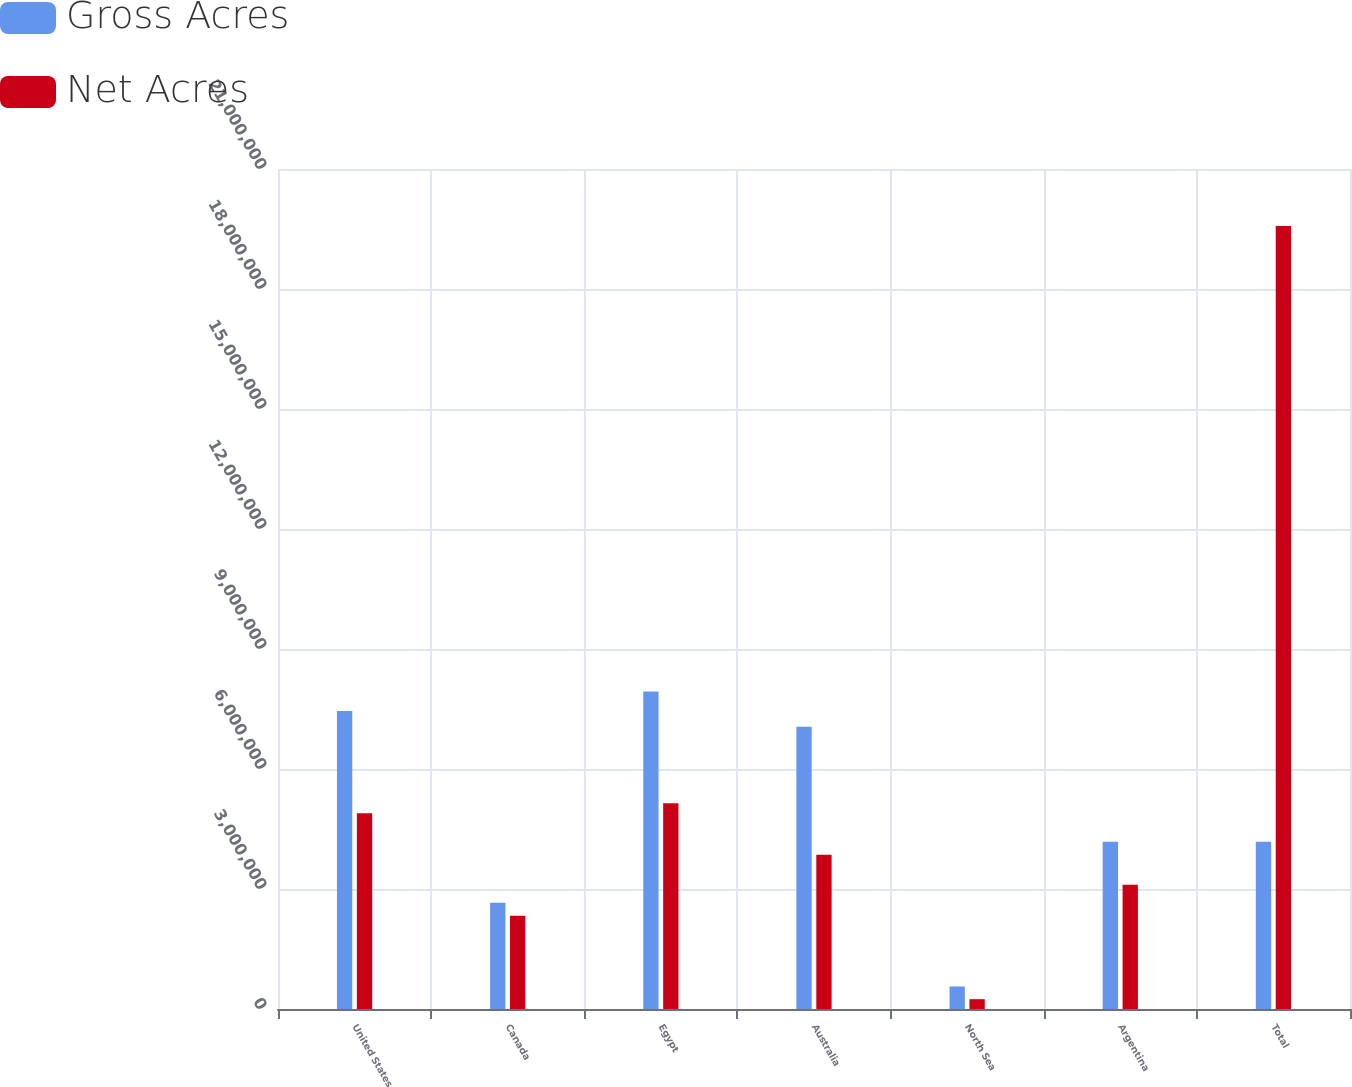Convert chart to OTSL. <chart><loc_0><loc_0><loc_500><loc_500><stacked_bar_chart><ecel><fcel>United States<fcel>Canada<fcel>Egypt<fcel>Australia<fcel>North Sea<fcel>Argentina<fcel>Total<nl><fcel>Gross Acres<fcel>7.44749e+06<fcel>2.65932e+06<fcel>7.93469e+06<fcel>7.05804e+06<fcel>563129<fcel>4.18207e+06<fcel>4.18207e+06<nl><fcel>Net Acres<fcel>4.89644e+06<fcel>2.32884e+06<fcel>5.14216e+06<fcel>3.85435e+06<fcel>245729<fcel>3.10697e+06<fcel>1.95745e+07<nl></chart> 